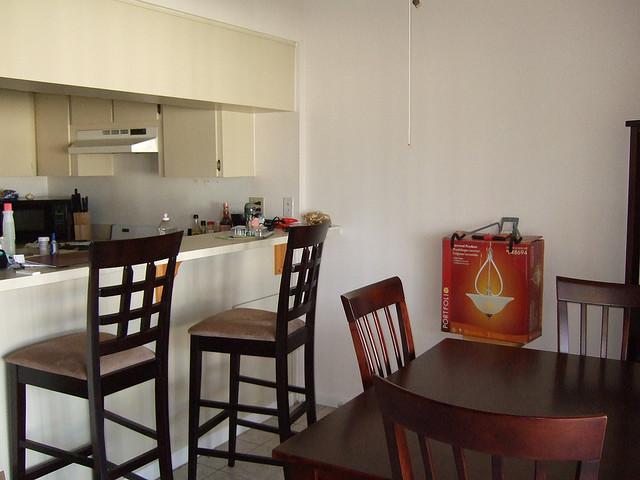Who sits in the wooden chairs?
Concise answer only. People. What are the chairs and the table made out of?
Keep it brief. Wood. How many sets of matching chairs are in the photo?
Answer briefly. 2. Is the kitchen tidy?
Be succinct. Yes. 